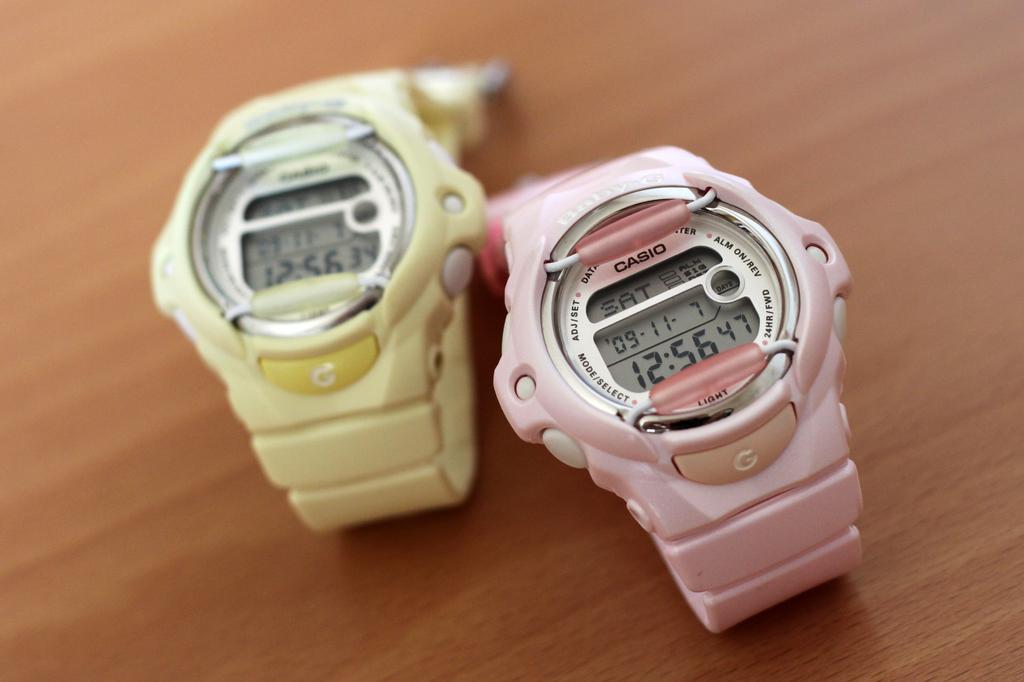How many seconds are shown on the watch on the right?
Offer a very short reply. 47. What brand is the pink watch?
Offer a very short reply. Casio. 